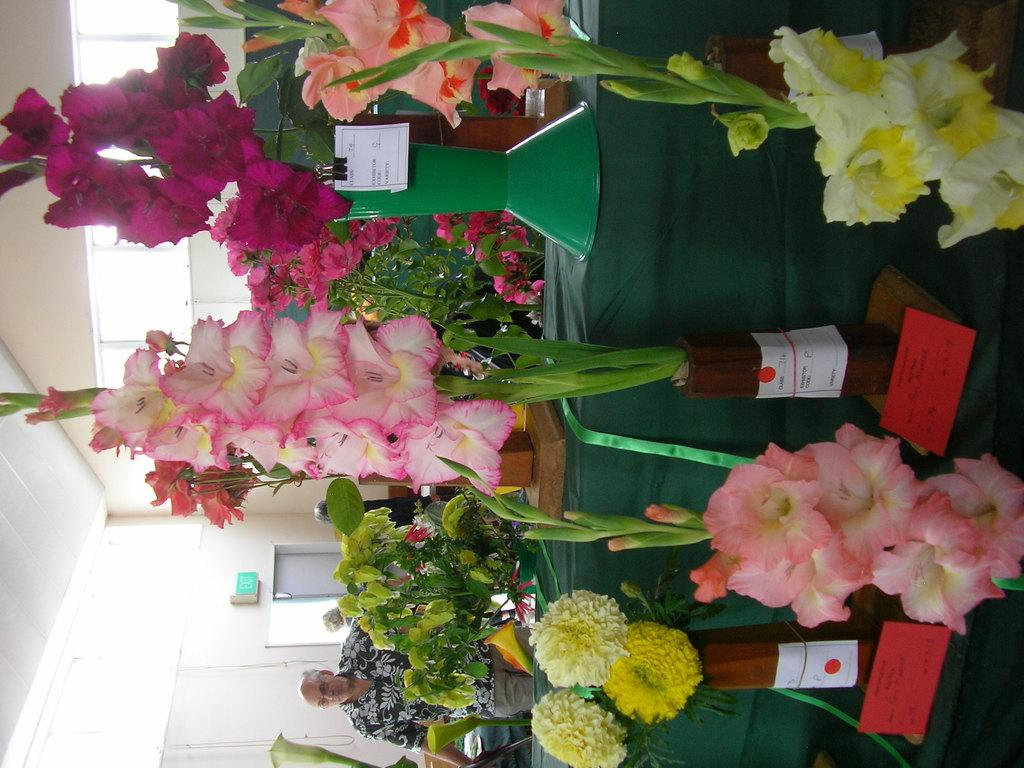What objects are in the foreground of the image? There are flower pots in the foreground of the image. What can be seen in the background of the image? There is a person and a door in the background of the image. Can you describe the person in the background? The provided facts do not give any information about the person's appearance or characteristics. What type of boot is the mother wearing in the image? There is no mention of a mother or a boot in the provided facts, so we cannot answer this question based on the image. 